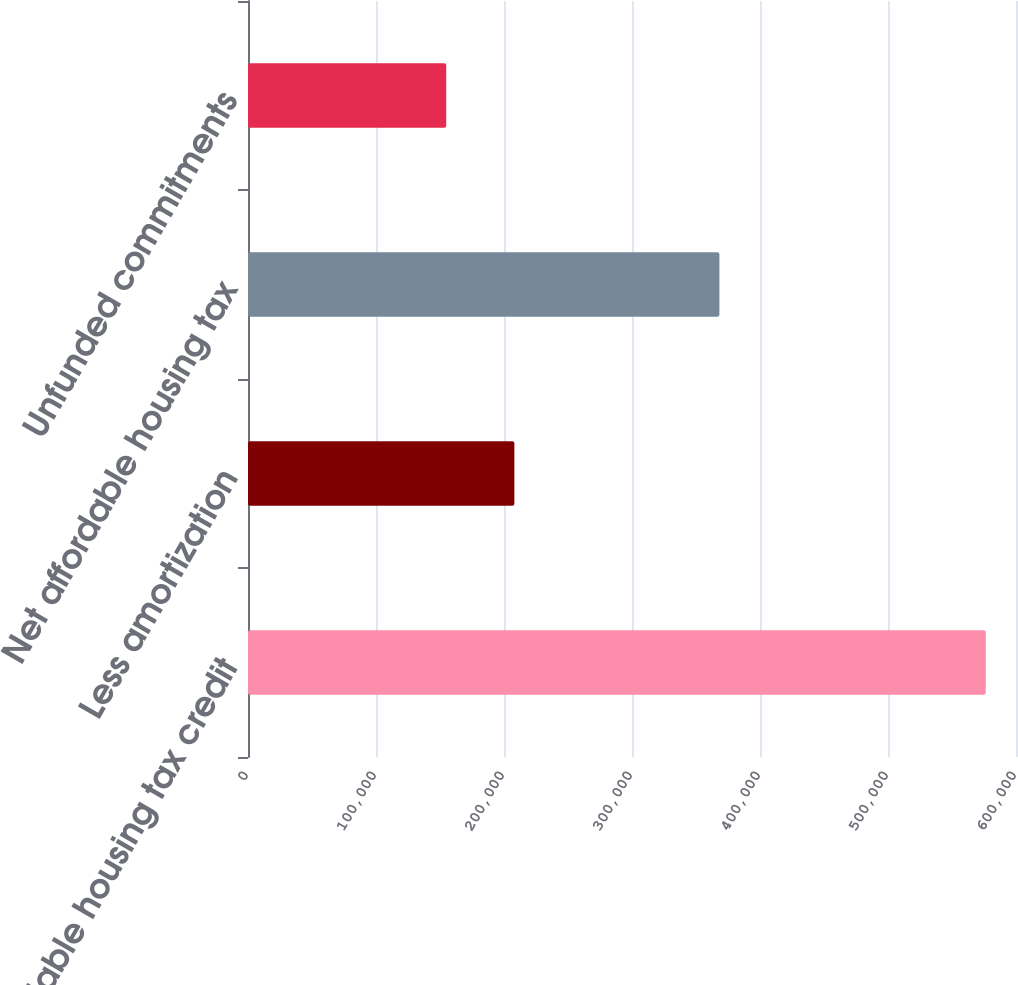<chart> <loc_0><loc_0><loc_500><loc_500><bar_chart><fcel>Affordable housing tax credit<fcel>Less amortization<fcel>Net affordable housing tax<fcel>Unfunded commitments<nl><fcel>576381<fcel>208098<fcel>368283<fcel>154861<nl></chart> 